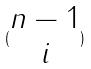Convert formula to latex. <formula><loc_0><loc_0><loc_500><loc_500>( \begin{matrix} n - 1 \\ i \end{matrix} )</formula> 